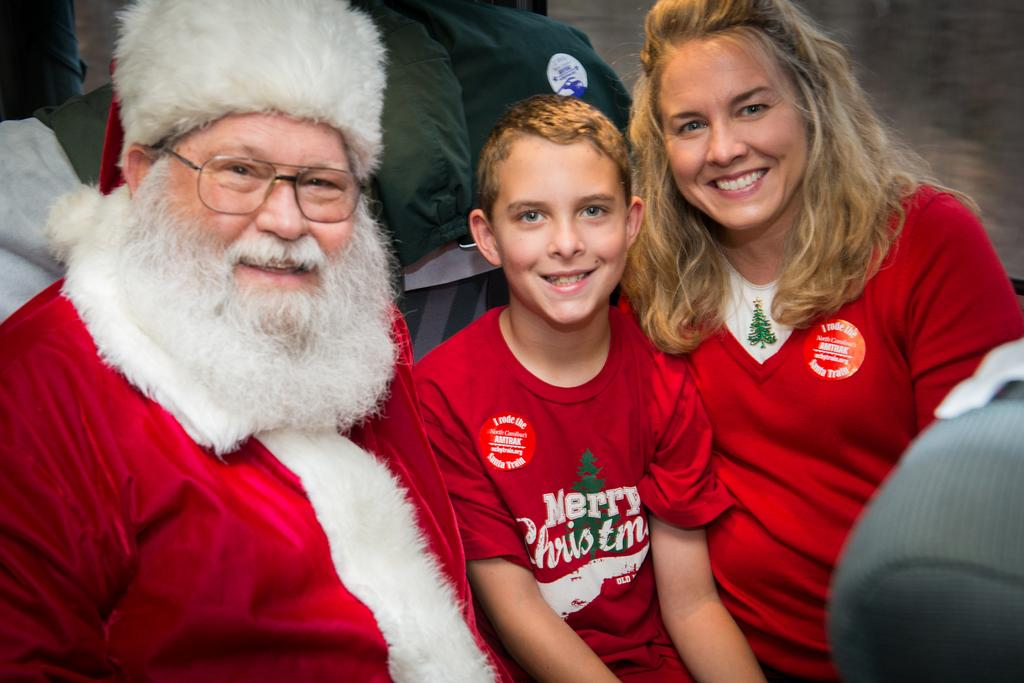<image>
Render a clear and concise summary of the photo. A boy is wearing a "Merry Christmas" shirt next to Santa. 